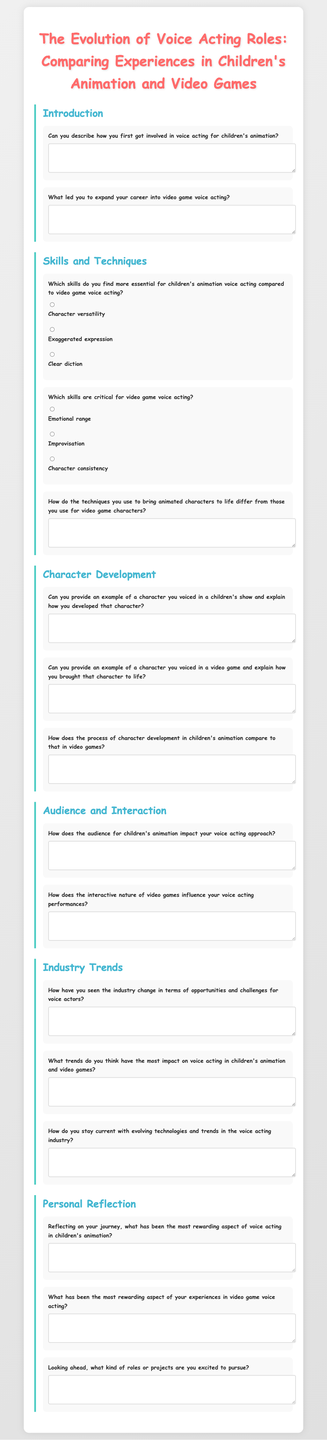What is the title of the questionnaire? The title is stated at the top of the document as the main heading.
Answer: The Evolution of Voice Acting Roles: Comparing Experiences in Children's Animation and Video Games What is the first section in the questionnaire? The first section focuses on the introduction to the questionnaire's topic.
Answer: Introduction Which skills are deemed essential for children's animation voice acting? The document offers multiple choice options for skills essential in children's animation.
Answer: Character versatility What example must the participant provide in the Character Development section? This section requires examples of characters from both children's animation and video games.
Answer: A character voiced in a children's show How many main sections does the questionnaire contain? The main sections can be counted based on headers throughout the document.
Answer: Five What do the audience impact questions relate to? These questions relate to how different audience types influence voice acting approaches.
Answer: Audience and Interaction What aspect of voice acting does the document ask about in terms of rewards? The questionnaire specifically asks about rewards from both children's animation and video game voice acting experiences.
Answer: Personal Reflection 